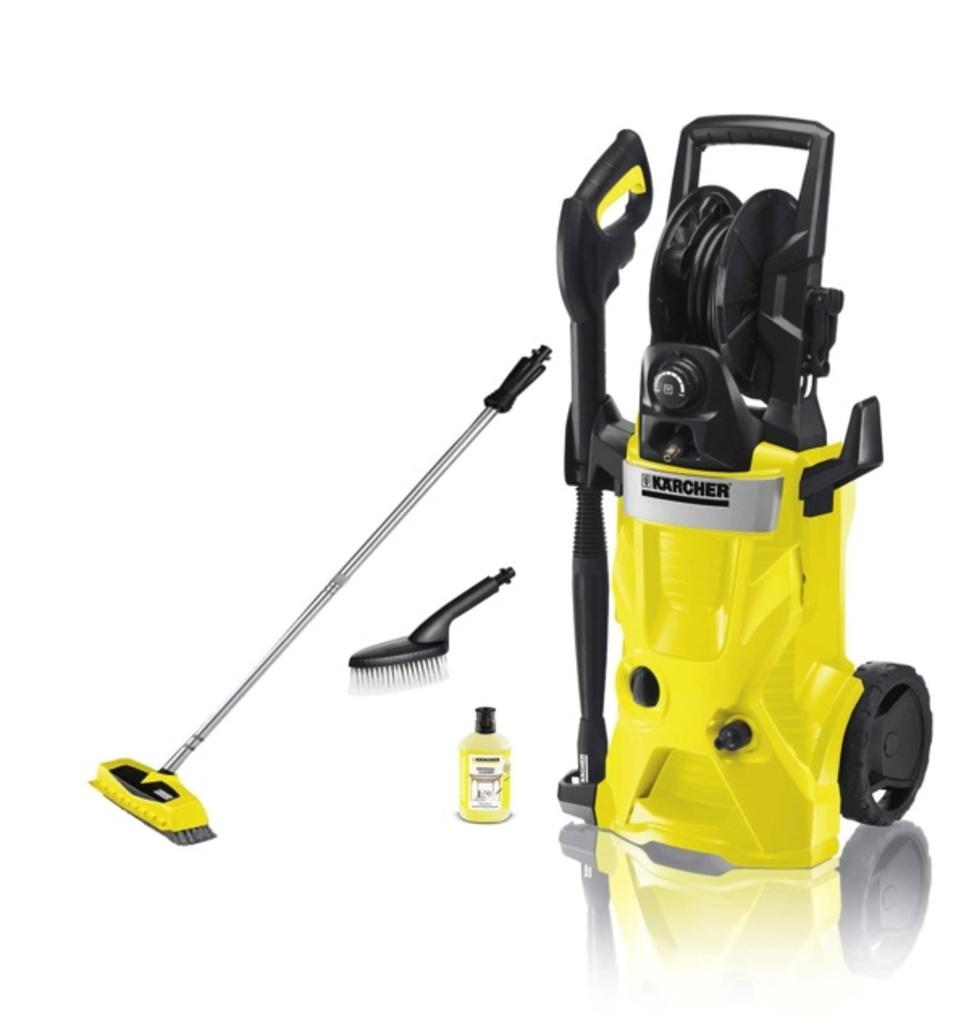What cleaning appliance is visible in the image? There is a vacuum cleaner in the image. What type of container is present in the image? There is a bottle in the image. What type of cleaning tool is visible in the image? There is a brush in the image. Can you describe the brush with a longer handle in the image? There is a long handle brush in the image. What type of paste is used for stitching in the image? There is no paste or stitching present in the image; it features a vacuum cleaner, a bottle, a brush, and a long handle brush. 